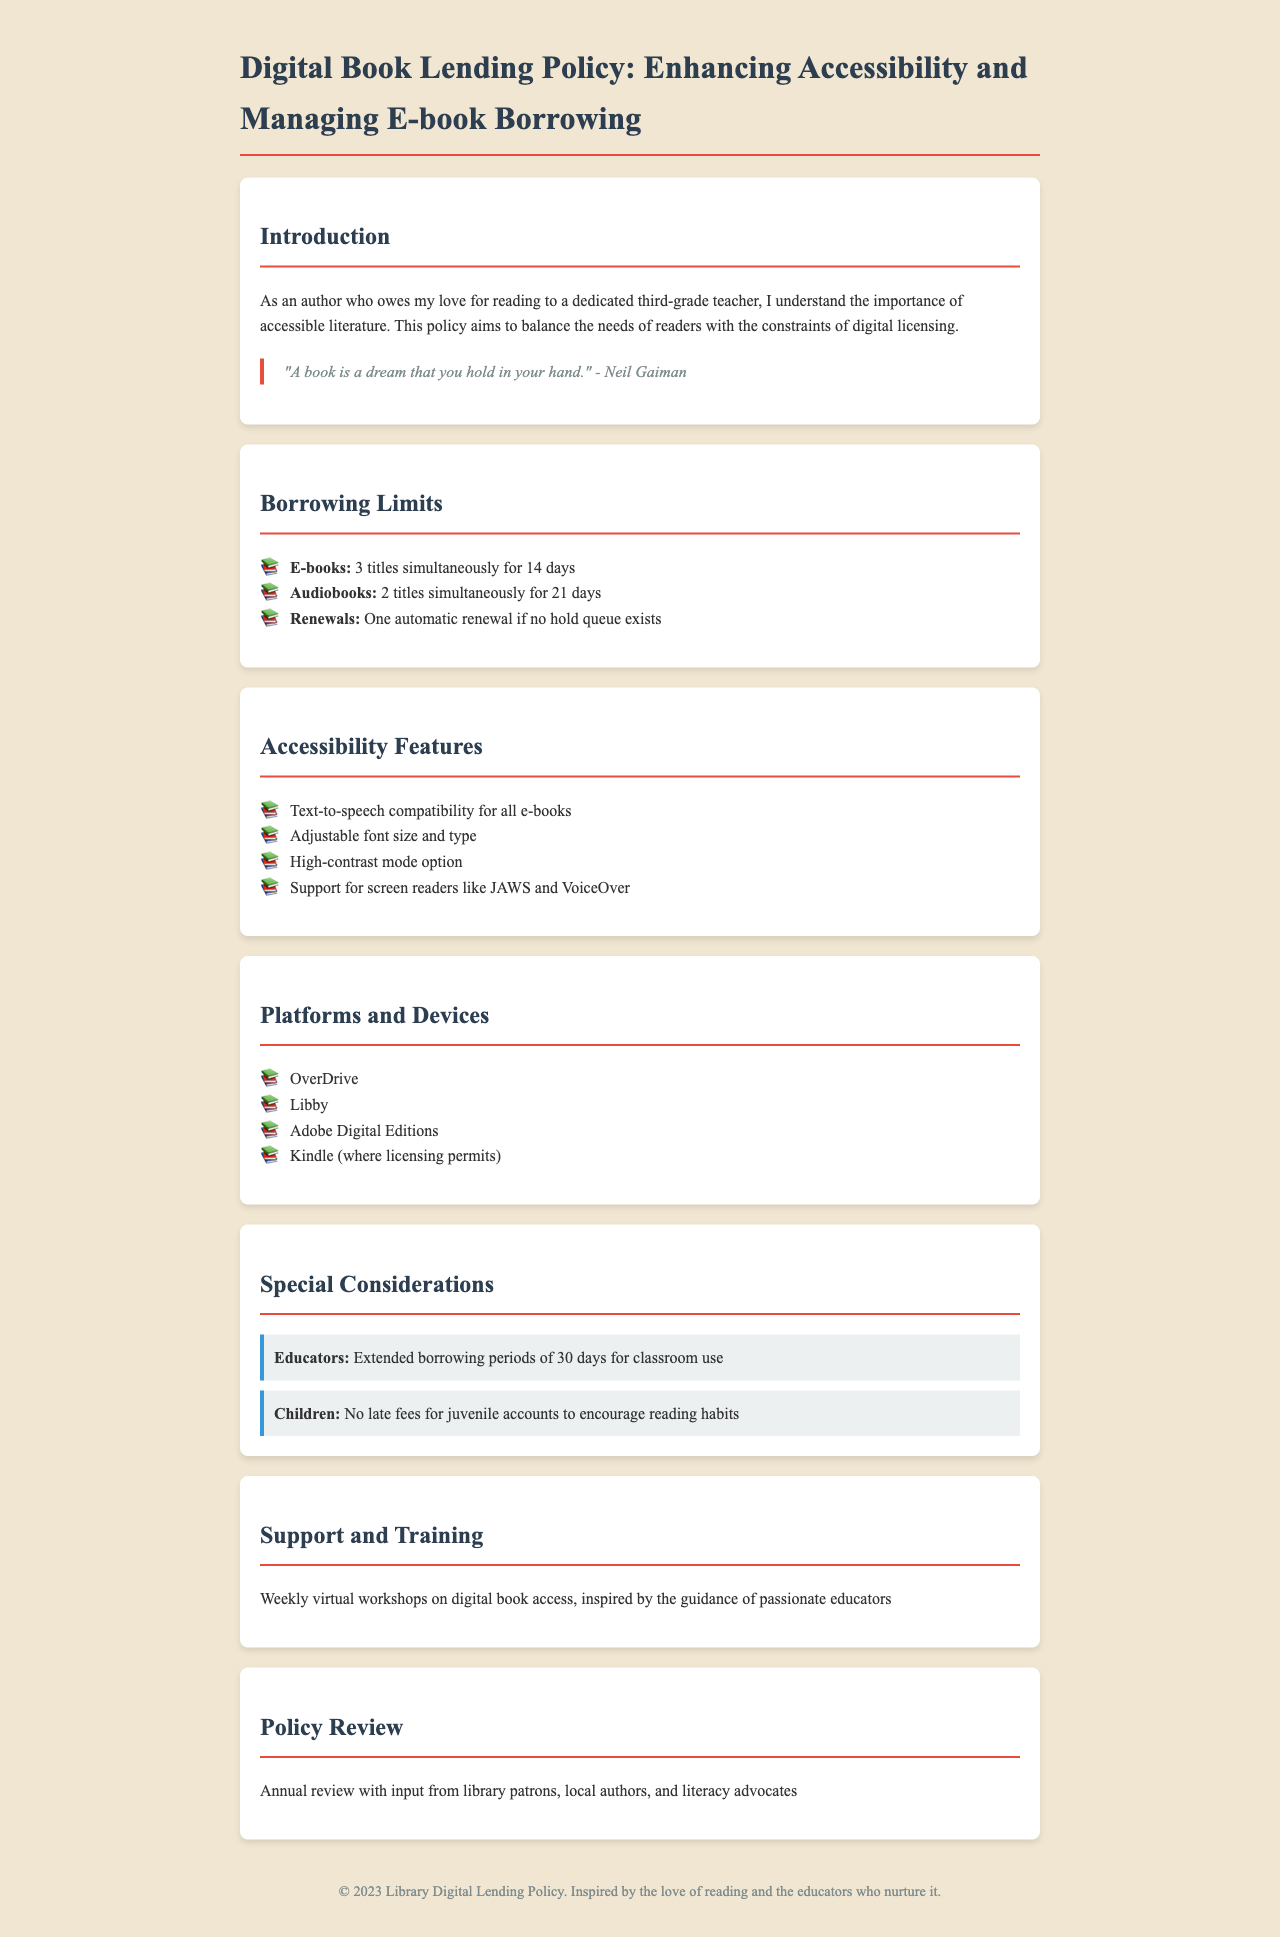What is the borrowing limit for e-books? The document specifies that borrowers can have 3 titles simultaneously for 14 days.
Answer: 3 titles simultaneously for 14 days What is the renewal policy for e-books? The policy states that there is one automatic renewal if no hold queue exists.
Answer: One automatic renewal How long is the borrowing period for audiobooks? According to the document, the borrowing period for audiobooks is 21 days.
Answer: 21 days What special borrowing consideration is given to educators? The document mentions that educators receive extended borrowing periods of 30 days for classroom use.
Answer: 30 days What accessibility feature supports individuals with visual impairments? The policy lists support for screen readers like JAWS and VoiceOver as a key accessibility feature.
Answer: Screen readers like JAWS and VoiceOver How many titles can juvenile accounts borrow without late fees? The document indicates that there are no late fees for juvenile accounts to encourage reading habits.
Answer: No late fees Which platforms are mentioned for accessing digital books? The policy lists platforms including OverDrive, Libby, Adobe Digital Editions, and Kindle.
Answer: OverDrive, Libby, Adobe Digital Editions, and Kindle What is the main theme of the Introduction? The introduction emphasizes the importance of accessible literature and a balance between reader needs and digital licensing.
Answer: Accessible literature How often is the policy reviewed? The document states that there is an annual review of the policy.
Answer: Annual review 